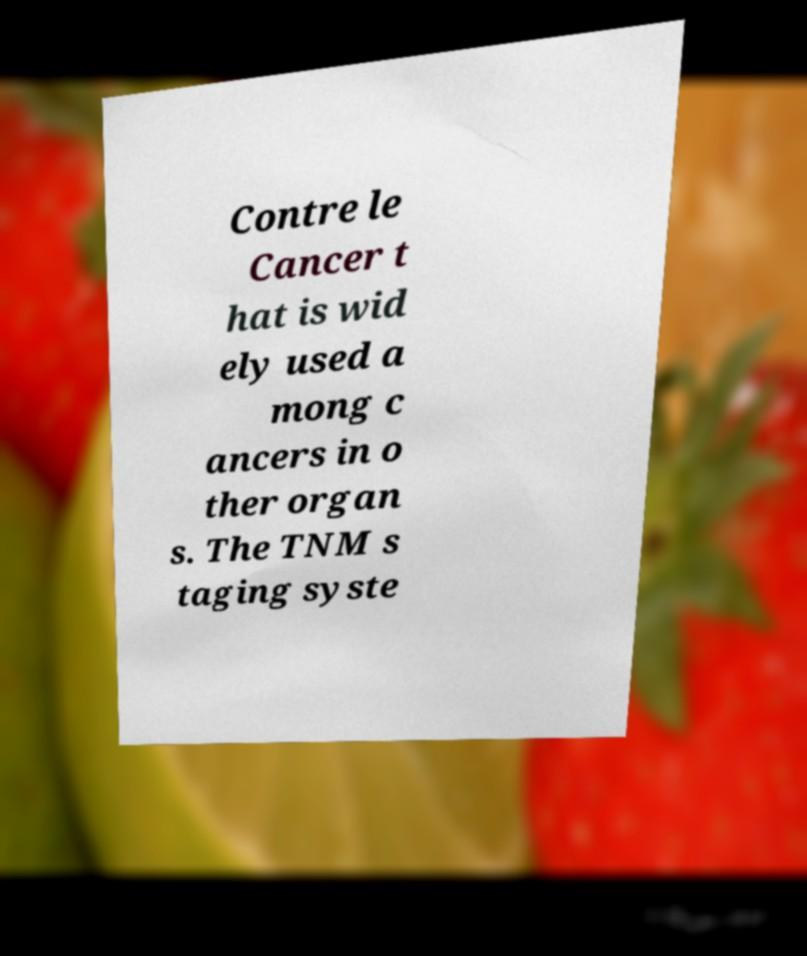There's text embedded in this image that I need extracted. Can you transcribe it verbatim? Contre le Cancer t hat is wid ely used a mong c ancers in o ther organ s. The TNM s taging syste 